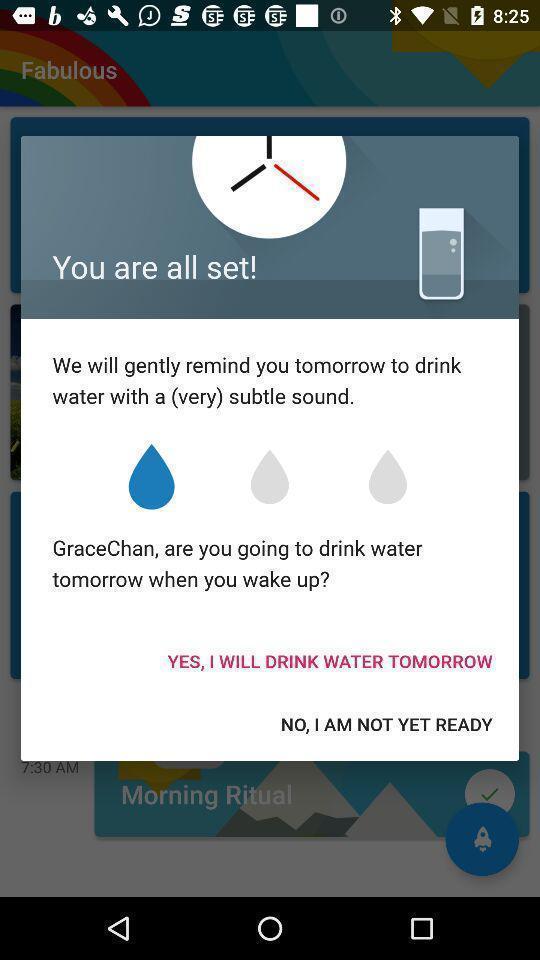Explain the elements present in this screenshot. Pop-up shows all set details in a fitness app. 